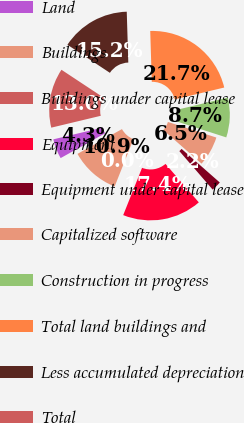Convert chart to OTSL. <chart><loc_0><loc_0><loc_500><loc_500><pie_chart><fcel>Land<fcel>Buildings<fcel>Buildings under capital lease<fcel>Equipment<fcel>Equipment under capital lease<fcel>Capitalized software<fcel>Construction in progress<fcel>Total land buildings and<fcel>Less accumulated depreciation<fcel>Total<nl><fcel>4.35%<fcel>10.87%<fcel>0.0%<fcel>17.39%<fcel>2.17%<fcel>6.52%<fcel>8.7%<fcel>21.74%<fcel>15.22%<fcel>13.04%<nl></chart> 